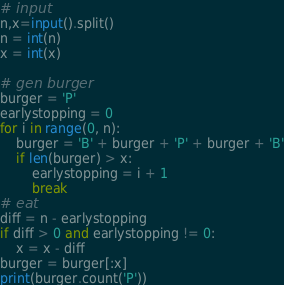<code> <loc_0><loc_0><loc_500><loc_500><_Python_># input
n,x=input().split()
n = int(n)
x = int(x)

# gen burger
burger = 'P'
earlystopping = 0
for i in range(0, n):
    burger = 'B' + burger + 'P' + burger + 'B'
    if len(burger) > x:
        earlystopping = i + 1
        break
# eat
diff = n - earlystopping
if diff > 0 and earlystopping != 0:
    x = x - diff
burger = burger[:x]
print(burger.count('P'))</code> 